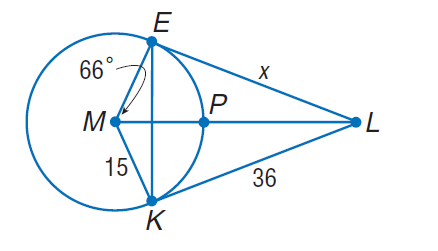Answer the mathemtical geometry problem and directly provide the correct option letter.
Question: Find x. Assume that segments that appear to be tangent are tangent.
Choices: A: 15 B: 21 C: 36 D: 72 C 